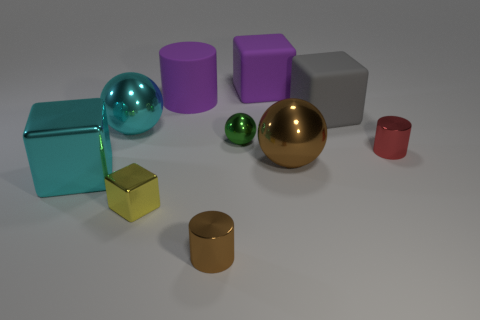There is a large ball that is on the left side of the purple block; is its color the same as the big metallic block?
Keep it short and to the point. Yes. What number of cylinders are on the left side of the big brown metallic sphere and in front of the big purple rubber cylinder?
Provide a succinct answer. 1. There is a purple object that is the same shape as the gray thing; what is its size?
Your answer should be very brief. Large. There is a large cube in front of the big brown metal sphere behind the tiny metal cube; how many yellow cubes are right of it?
Offer a terse response. 1. What color is the cylinder on the right side of the brown object in front of the large shiny block?
Offer a very short reply. Red. How many other things are there of the same material as the small green ball?
Your response must be concise. 6. How many gray things are to the right of the brown thing that is in front of the small metal cube?
Provide a succinct answer. 1. Do the big thing behind the purple matte cylinder and the cylinder behind the gray cube have the same color?
Keep it short and to the point. Yes. Are there fewer big cyan balls than small gray rubber spheres?
Offer a terse response. No. The cyan metallic object that is behind the cylinder to the right of the large gray matte object is what shape?
Give a very brief answer. Sphere. 